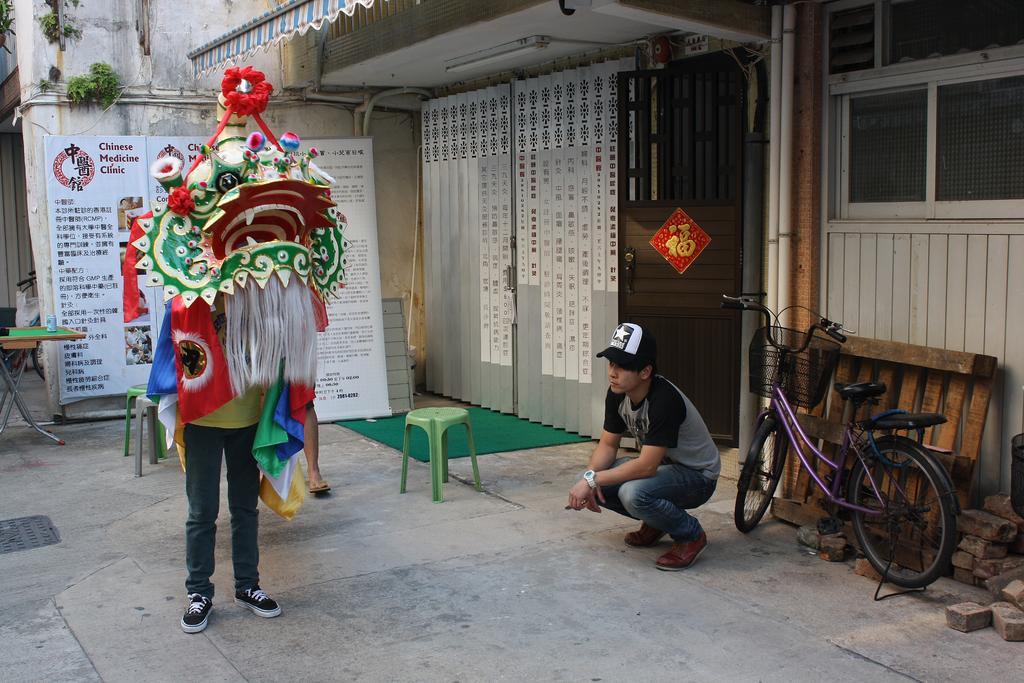Could you give a brief overview of what you see in this image? In this image at the center person is standing. Behind him there are two chairs. At the background there is a banner. Beside the banner there is a table. At the right side of the image there is a building. In front of the building one person is sitting. Behind him there is a cycle and some bricks are on the floor. 